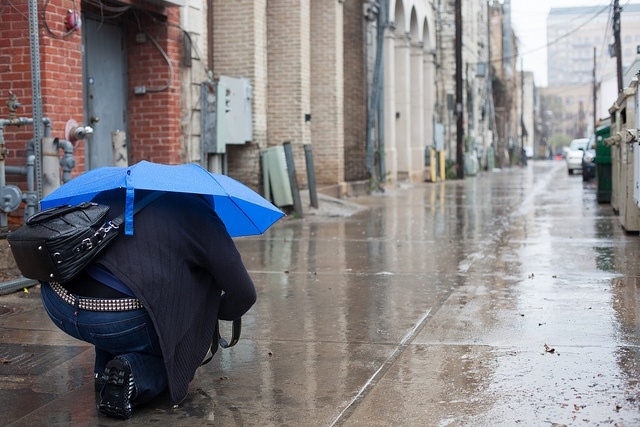Describe the objects in this image and their specific colors. I can see people in brown, black, navy, gray, and darkgray tones, umbrella in brown, lightblue, and blue tones, handbag in brown, black, gray, navy, and darkblue tones, car in brown, lightgray, darkgray, gray, and black tones, and car in brown, black, lightgray, lightblue, and darkgray tones in this image. 